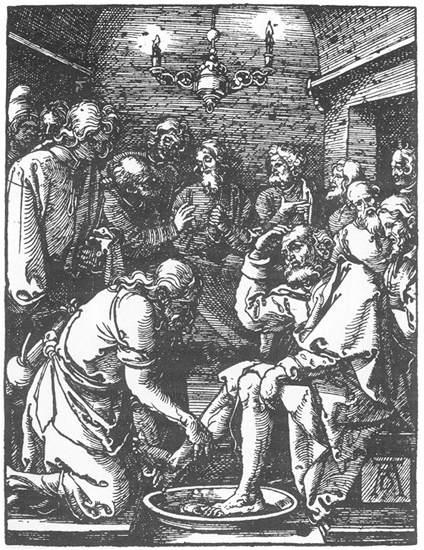Imagine a fantastical story starting from this image. Where could the narrative go? In a fantastical twist, as the man finishes washing the feet and the group concludes their solemn ritual, an unusual light begins to emanate from the water basin used in the foot washing. The light intensifies and forms into a glowing portal, enticing the gathered individuals with visions of an alternate realm. Intrigued and perhaps recognizing a divine invitation, they step through the portal, arriving in an ethereal land where time behaves differently, and mythical creatures roam. In this alternate reality, the group must navigate a series of trials that test their virtues of humility, service, and unity. Their journey through enchanted forests, mystical mountains, and ancient temples brings them face-to-face with beings of folklore and myth. Along the way, they uncover hidden truths about the nature of their world and the cosmic balance of their existence, ultimately returning to their original time and place – but profoundly changed, carrying newfound wisdom and a heightened sense of purpose. What elements in the image support a narrative about mysticism or hidden powers? The image's use of light and shadow, along with its detailed and evocative style, lends itself to an interpretation rich in mysticism. The intense focus and reverence shown by the figures, the act of foot washing – a practice laden with symbolism – and the intricate detailing of their garments and surroundings all suggest layers of hidden meaning. The chandelier, a source of illumination in the otherwise dim room, could symbolize enlightenment or the presence of a higher power. The brick walls, solid yet weathered, hint at ancient secrets and long-standing traditions, fostering a sense of mystical depth and the possibility of hidden powers within the setting. 